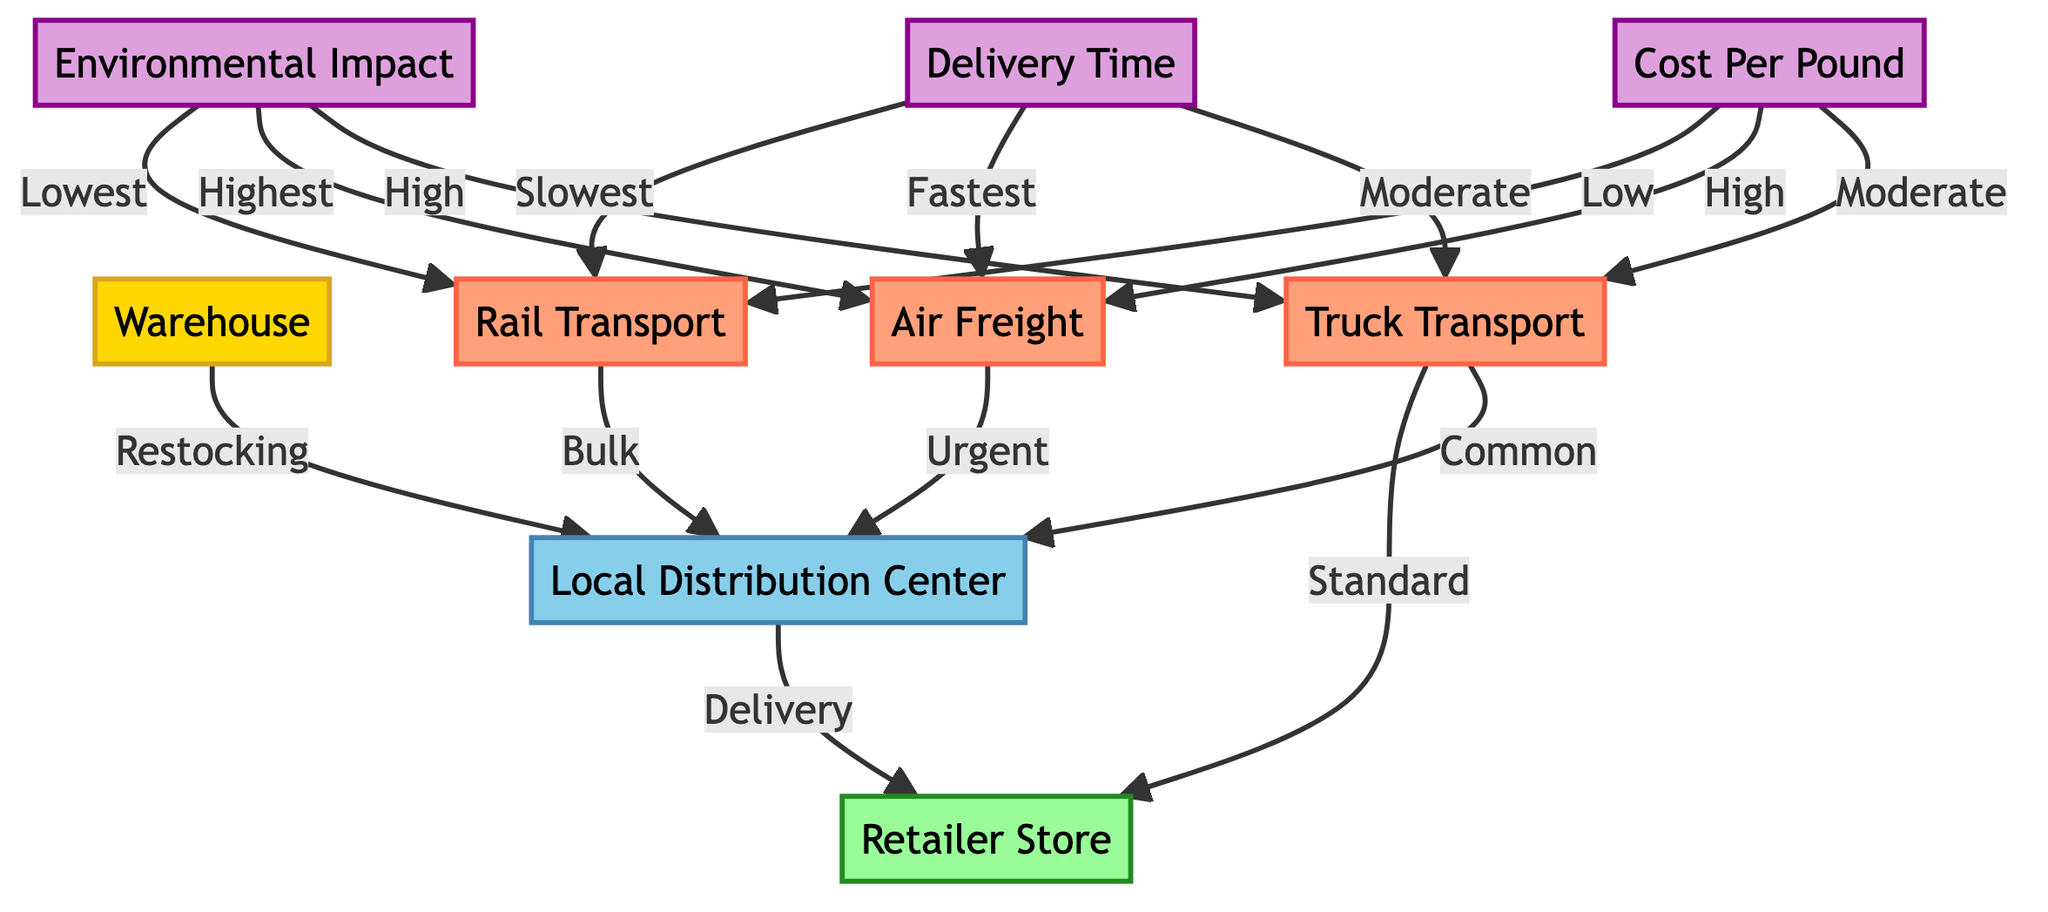What is the primary function of the Warehouse node? The Warehouse node is connected to the Local Distribution Center with a "Restocking" relationship, indicating that its primary function involves supplying stock to the LDC.
Answer: Restocking How many transportation methods are represented in the diagram? Three transportation methods are represented: Truck Transport, Air Freight, and Rail Transport. Counting these nodes gives a total of three.
Answer: Three Which transportation method is described as having the highest cost per pound? By looking at the Cost Per Pound metric, the diagram indicates that Air Freight has a "High" cost per pound compared to the others, which specify "Moderate" and "Low."
Answer: High What is the delivery time associated with Air Freight? The Delivery Time metric shows that Air Freight is marked as the "Fastest" method of transport, indicating it has the shortest delivery time.
Answer: Fastest Which transport method has the lowest environmental impact? The Environmental Impact metric indicates that Rail Transport has a "Lowest" environmental impact, making it the most environmentally friendly option of the three.
Answer: Lowest What type of deliveries does the Truck Transport method typically handle? The diagram specifies that Truck Transport delivers "Common" loads to the Local Distribution Center and to Retailer Store, indicating standard deliveries.
Answer: Common Which method is considered to have the slowest delivery time? The Delivery Time metric states that Rail Transport is the "Slowest" method, so by analyzing this, it can be determined that it has the longest delivery time among the methods presented.
Answer: Slowest What is the relationship between the Local Distribution Center and the Retailer Store? The diagram shows an arrow from Local Distribution Center to Retailer Store labeled "Delivery," indicating that the LDC delivers products to the RS.
Answer: Delivery What kind of transportation method is used for bulk deliveries? The diagram designates Rail Transport as the method used for "Bulk" deliveries to the Local Distribution Center, indicating it handles larger quantities.
Answer: Bulk 